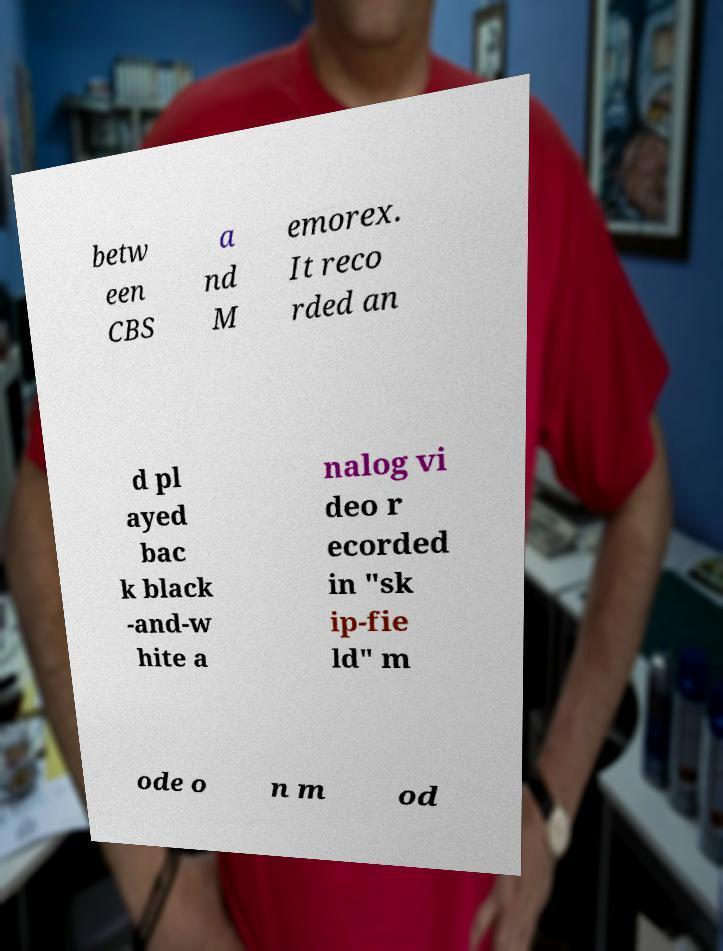Can you accurately transcribe the text from the provided image for me? betw een CBS a nd M emorex. It reco rded an d pl ayed bac k black -and-w hite a nalog vi deo r ecorded in "sk ip-fie ld" m ode o n m od 